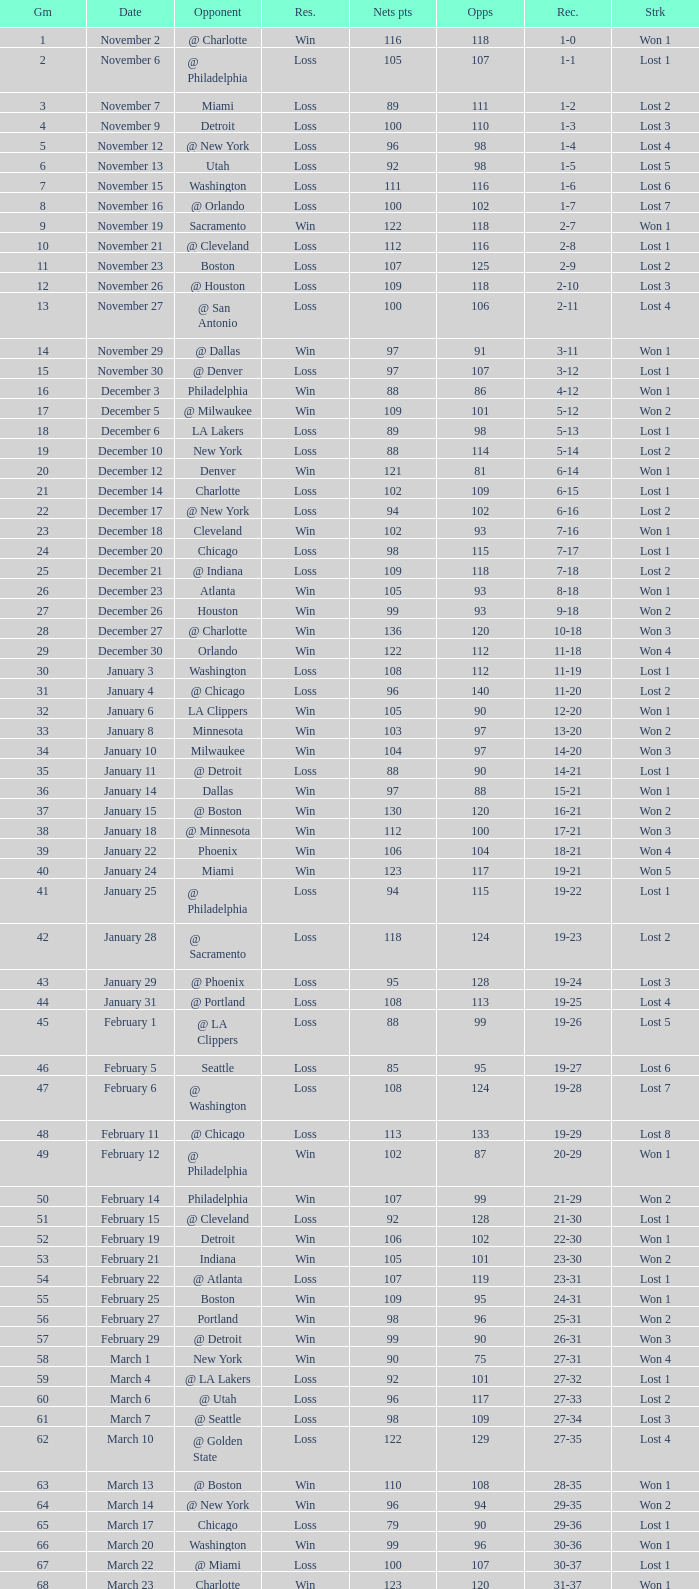Which opponent is from february 12? @ Philadelphia. 